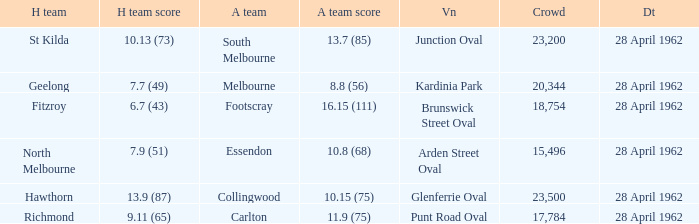Would you mind parsing the complete table? {'header': ['H team', 'H team score', 'A team', 'A team score', 'Vn', 'Crowd', 'Dt'], 'rows': [['St Kilda', '10.13 (73)', 'South Melbourne', '13.7 (85)', 'Junction Oval', '23,200', '28 April 1962'], ['Geelong', '7.7 (49)', 'Melbourne', '8.8 (56)', 'Kardinia Park', '20,344', '28 April 1962'], ['Fitzroy', '6.7 (43)', 'Footscray', '16.15 (111)', 'Brunswick Street Oval', '18,754', '28 April 1962'], ['North Melbourne', '7.9 (51)', 'Essendon', '10.8 (68)', 'Arden Street Oval', '15,496', '28 April 1962'], ['Hawthorn', '13.9 (87)', 'Collingwood', '10.15 (75)', 'Glenferrie Oval', '23,500', '28 April 1962'], ['Richmond', '9.11 (65)', 'Carlton', '11.9 (75)', 'Punt Road Oval', '17,784', '28 April 1962']]} What away team played at Brunswick Street Oval? Footscray. 